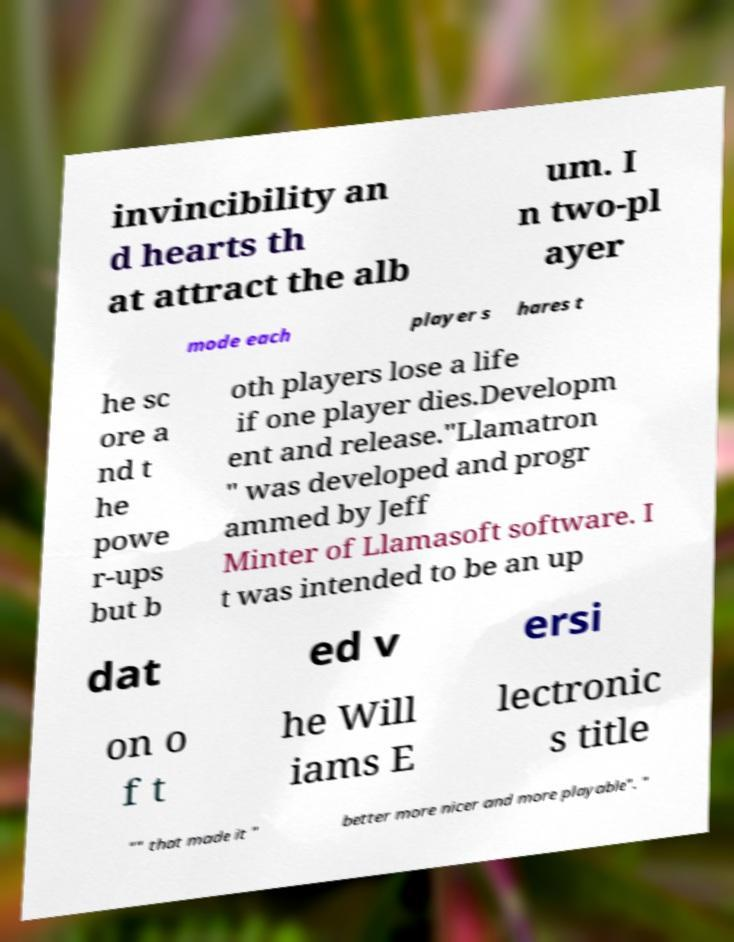Could you assist in decoding the text presented in this image and type it out clearly? invincibility an d hearts th at attract the alb um. I n two-pl ayer mode each player s hares t he sc ore a nd t he powe r-ups but b oth players lose a life if one player dies.Developm ent and release."Llamatron " was developed and progr ammed by Jeff Minter of Llamasoft software. I t was intended to be an up dat ed v ersi on o f t he Will iams E lectronic s title "" that made it " better more nicer and more playable". " 